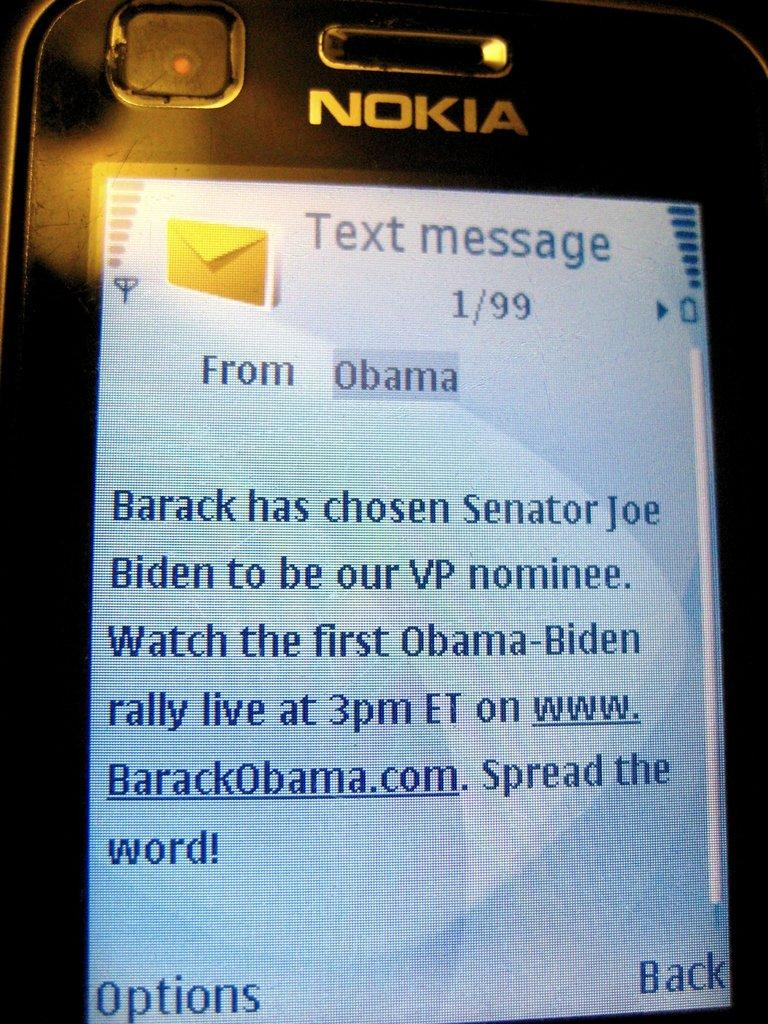<image>
Summarize the visual content of the image. Nokia phone showing a long message from Barack Obama 